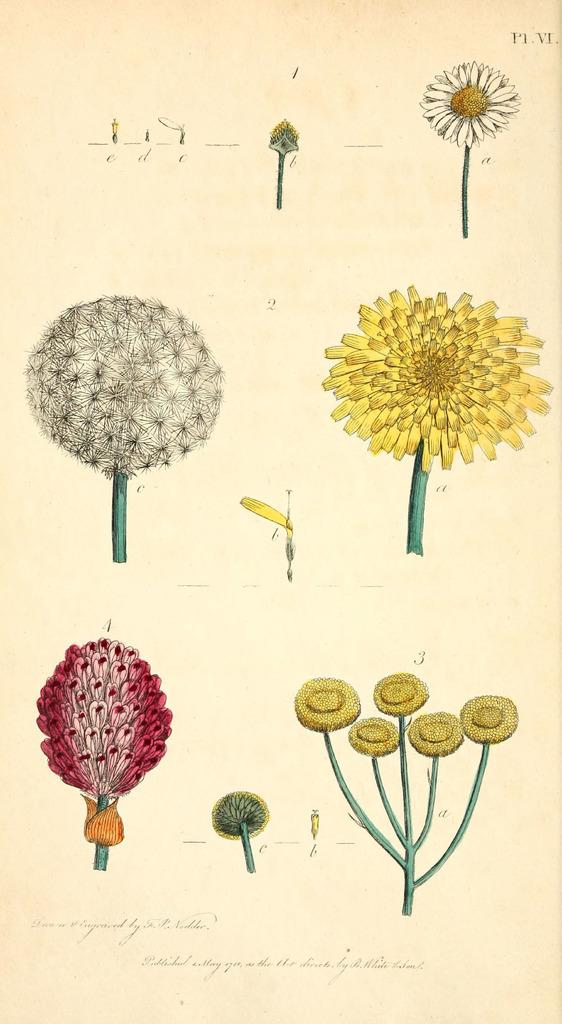What is the main object in the image? The main object in the image is a paper. What can be seen on the paper? There are different types of flowers depicted on the paper. Are there any words or symbols on the paper? Yes, there are letters on the paper. How does the paper help the person breathe in the image? There is no indication in the image that the paper is related to breathing or has any impact on a person's ability to breathe. 